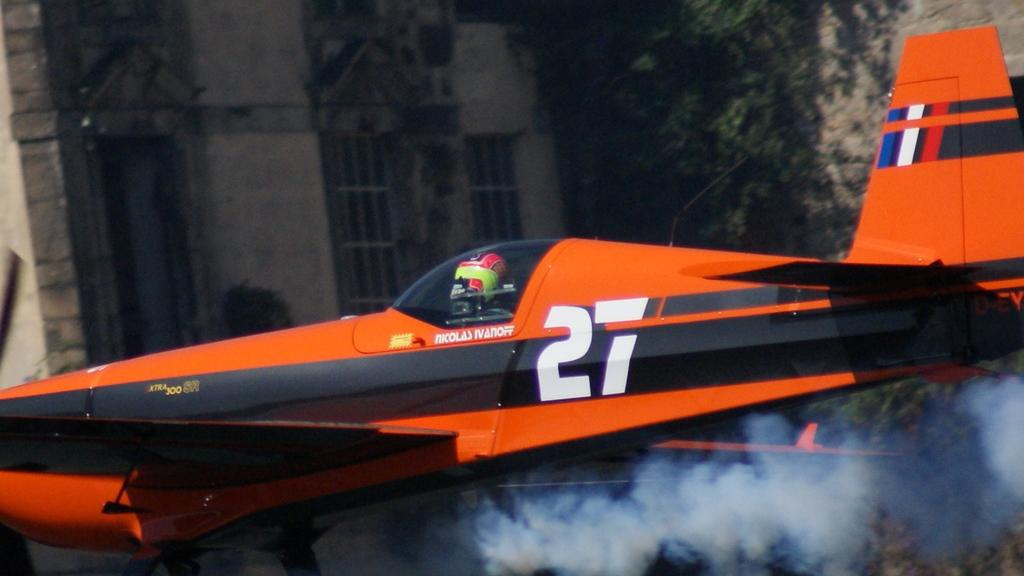<image>
Summarize the visual content of the image. An airplane has the name Nicolas Ivanoff on its side right below the pilot. 